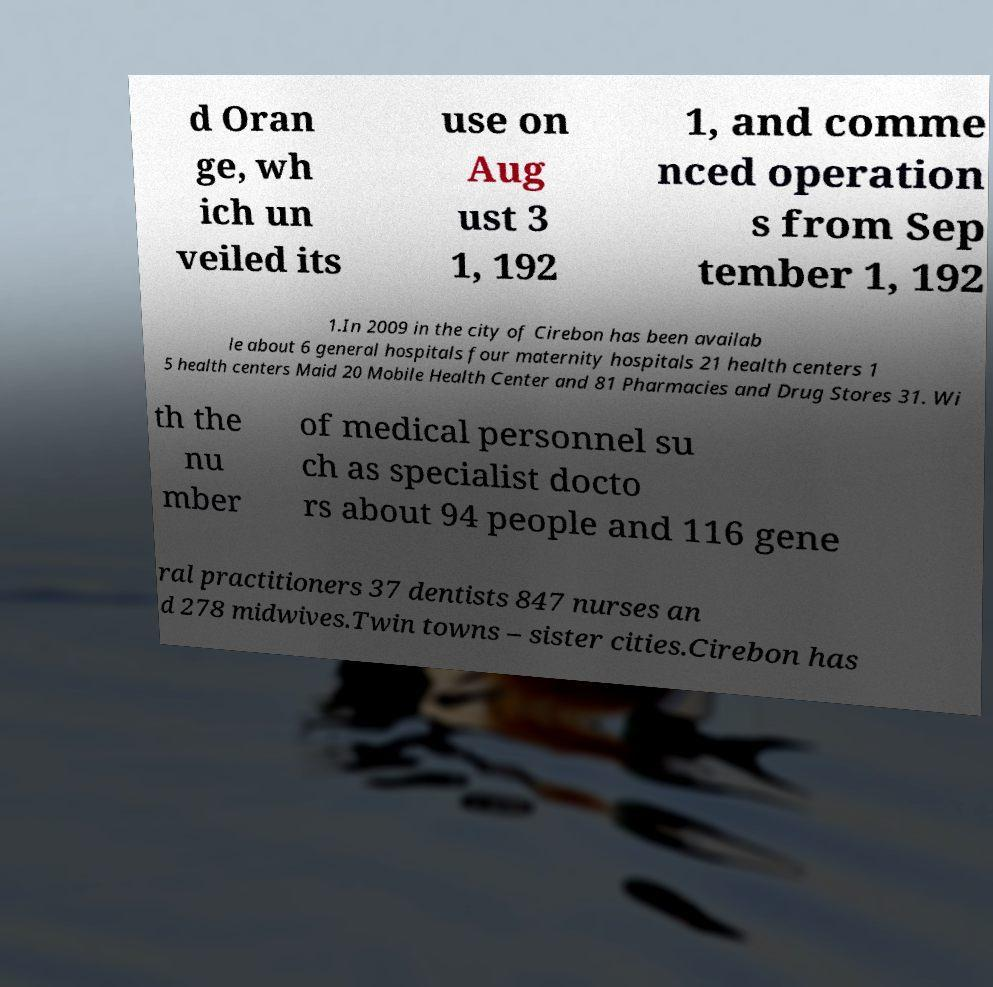I need the written content from this picture converted into text. Can you do that? d Oran ge, wh ich un veiled its use on Aug ust 3 1, 192 1, and comme nced operation s from Sep tember 1, 192 1.In 2009 in the city of Cirebon has been availab le about 6 general hospitals four maternity hospitals 21 health centers 1 5 health centers Maid 20 Mobile Health Center and 81 Pharmacies and Drug Stores 31. Wi th the nu mber of medical personnel su ch as specialist docto rs about 94 people and 116 gene ral practitioners 37 dentists 847 nurses an d 278 midwives.Twin towns – sister cities.Cirebon has 